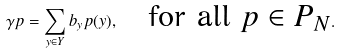Convert formula to latex. <formula><loc_0><loc_0><loc_500><loc_500>\gamma p = \sum _ { y \in Y } b _ { y } p ( y ) , \quad \text {for all $p \in P_{N}$} .</formula> 